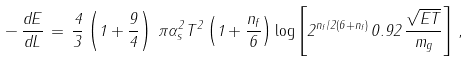Convert formula to latex. <formula><loc_0><loc_0><loc_500><loc_500>- \, \frac { d E } { d L } \, = \, \frac { 4 } { 3 } \left ( 1 + \frac { 9 } { 4 } \right ) \, \pi \alpha _ { s } ^ { 2 } T ^ { 2 } \left ( 1 + \frac { n _ { f } } { 6 } \right ) \log \left [ 2 ^ { n _ { f } / 2 ( 6 + n _ { f } ) } \, 0 . 9 2 \, \frac { \sqrt { E T } } { m _ { g } } \right ] \, ,</formula> 